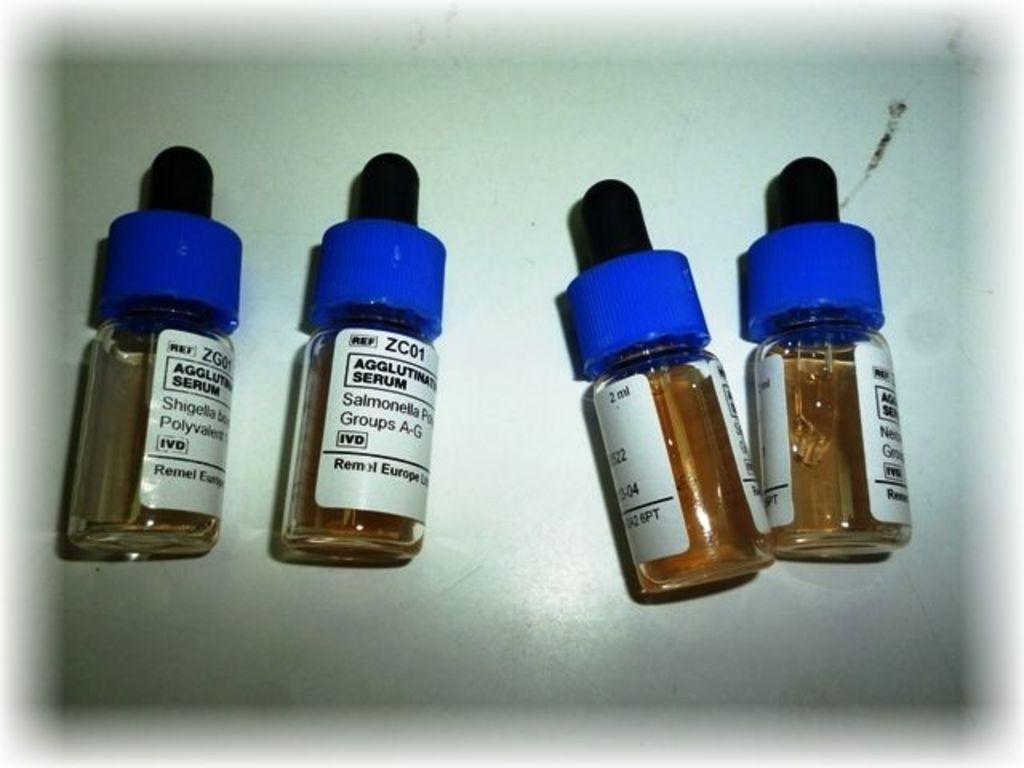<image>
Describe the image concisely. Four jars of a Serum with blue lids 